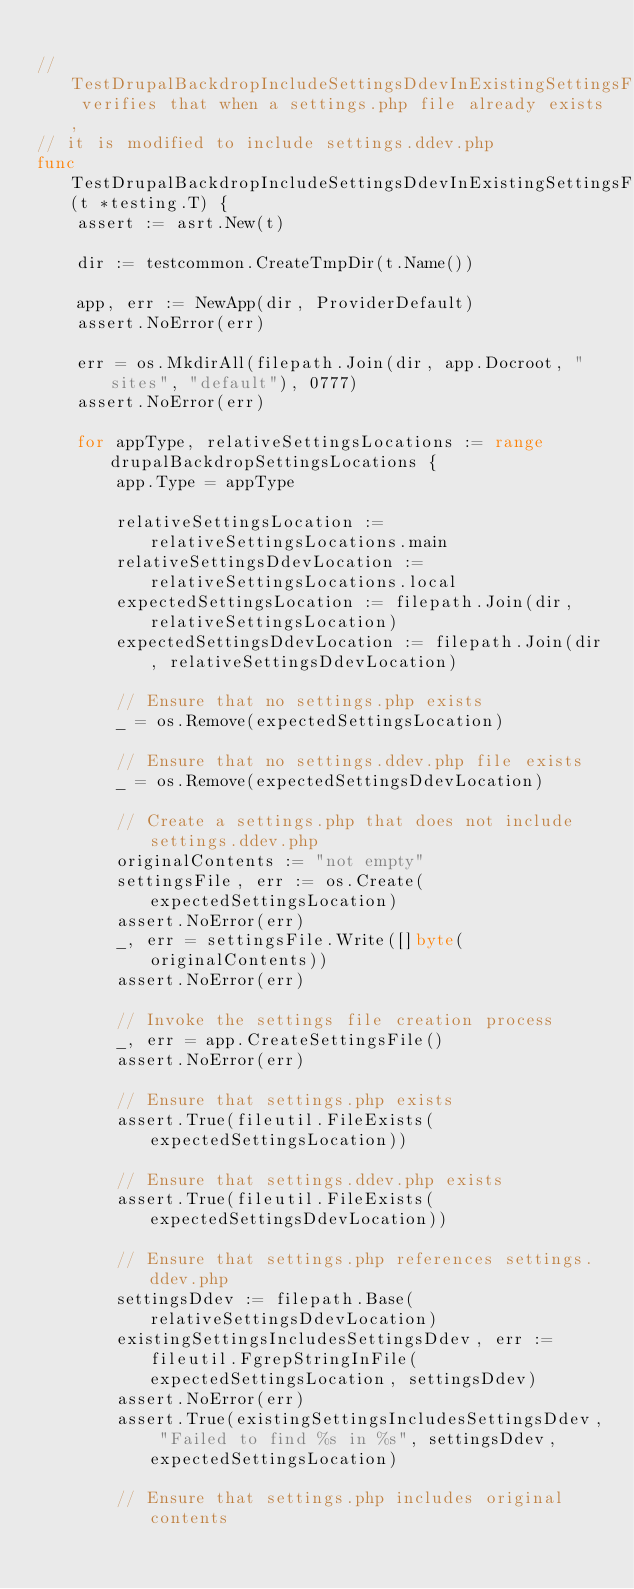Convert code to text. <code><loc_0><loc_0><loc_500><loc_500><_Go_>
// TestDrupalBackdropIncludeSettingsDdevInExistingSettingsFile verifies that when a settings.php file already exists,
// it is modified to include settings.ddev.php
func TestDrupalBackdropIncludeSettingsDdevInExistingSettingsFile(t *testing.T) {
	assert := asrt.New(t)

	dir := testcommon.CreateTmpDir(t.Name())

	app, err := NewApp(dir, ProviderDefault)
	assert.NoError(err)

	err = os.MkdirAll(filepath.Join(dir, app.Docroot, "sites", "default"), 0777)
	assert.NoError(err)

	for appType, relativeSettingsLocations := range drupalBackdropSettingsLocations {
		app.Type = appType

		relativeSettingsLocation := relativeSettingsLocations.main
		relativeSettingsDdevLocation := relativeSettingsLocations.local
		expectedSettingsLocation := filepath.Join(dir, relativeSettingsLocation)
		expectedSettingsDdevLocation := filepath.Join(dir, relativeSettingsDdevLocation)

		// Ensure that no settings.php exists
		_ = os.Remove(expectedSettingsLocation)

		// Ensure that no settings.ddev.php file exists
		_ = os.Remove(expectedSettingsDdevLocation)

		// Create a settings.php that does not include settings.ddev.php
		originalContents := "not empty"
		settingsFile, err := os.Create(expectedSettingsLocation)
		assert.NoError(err)
		_, err = settingsFile.Write([]byte(originalContents))
		assert.NoError(err)

		// Invoke the settings file creation process
		_, err = app.CreateSettingsFile()
		assert.NoError(err)

		// Ensure that settings.php exists
		assert.True(fileutil.FileExists(expectedSettingsLocation))

		// Ensure that settings.ddev.php exists
		assert.True(fileutil.FileExists(expectedSettingsDdevLocation))

		// Ensure that settings.php references settings.ddev.php
		settingsDdev := filepath.Base(relativeSettingsDdevLocation)
		existingSettingsIncludesSettingsDdev, err := fileutil.FgrepStringInFile(expectedSettingsLocation, settingsDdev)
		assert.NoError(err)
		assert.True(existingSettingsIncludesSettingsDdev, "Failed to find %s in %s", settingsDdev, expectedSettingsLocation)

		// Ensure that settings.php includes original contents</code> 